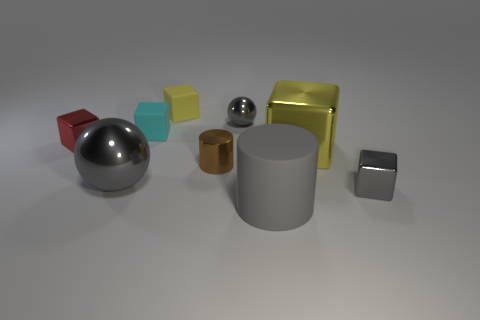Subtract all gray cubes. How many cubes are left? 4 Subtract all big cubes. How many cubes are left? 4 Subtract all green cubes. Subtract all red cylinders. How many cubes are left? 5 Add 1 yellow shiny blocks. How many objects exist? 10 Subtract all spheres. How many objects are left? 7 Add 2 green rubber cubes. How many green rubber cubes exist? 2 Subtract 1 red cubes. How many objects are left? 8 Subtract all large gray metal things. Subtract all tiny brown blocks. How many objects are left? 8 Add 7 cylinders. How many cylinders are left? 9 